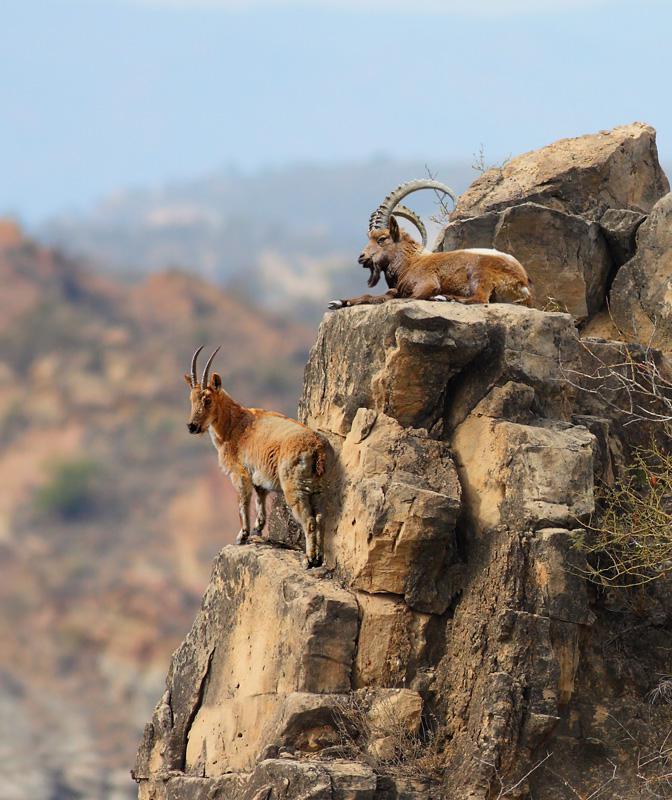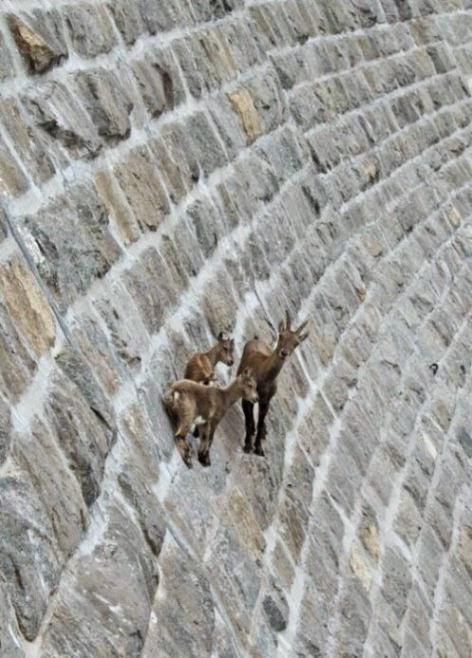The first image is the image on the left, the second image is the image on the right. Assess this claim about the two images: "Some of the animals are on a steep rock face.". Correct or not? Answer yes or no. Yes. 